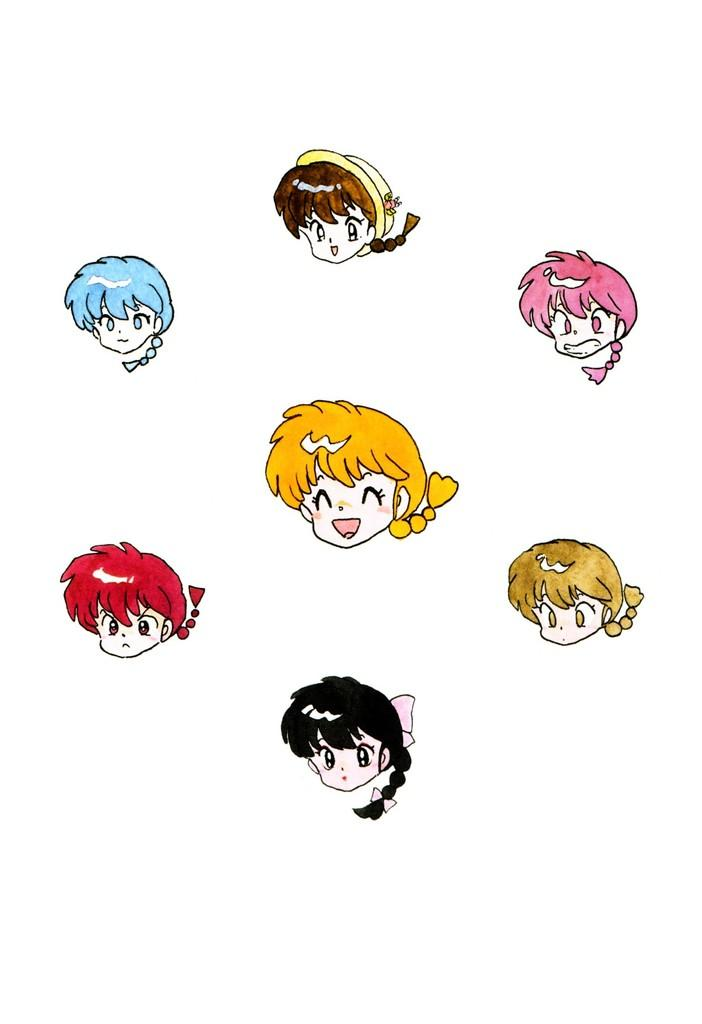What type of images are present in the image? There are clipart images of toys in the image. What color is the background of the image? The background of the image is white. Can you tell me which toys are selected for use in the image? There is no indication of a toy selection process in the image, as it only contains clipart images of toys. Is there a stream visible in the image? No, there is no stream present in the image; it only features clipart images of toys against a white background. 